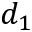Convert formula to latex. <formula><loc_0><loc_0><loc_500><loc_500>d _ { 1 }</formula> 